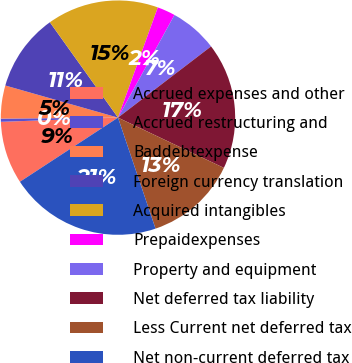Convert chart. <chart><loc_0><loc_0><loc_500><loc_500><pie_chart><fcel>Accrued expenses and other<fcel>Accrued restructuring and<fcel>Baddebtexpense<fcel>Foreign currency translation<fcel>Acquired intangibles<fcel>Prepaidexpenses<fcel>Property and equipment<fcel>Net deferred tax liability<fcel>Less Current net deferred tax<fcel>Net non-current deferred tax<nl><fcel>8.65%<fcel>0.44%<fcel>4.55%<fcel>10.71%<fcel>15.39%<fcel>2.49%<fcel>6.6%<fcel>17.45%<fcel>12.76%<fcel>20.97%<nl></chart> 